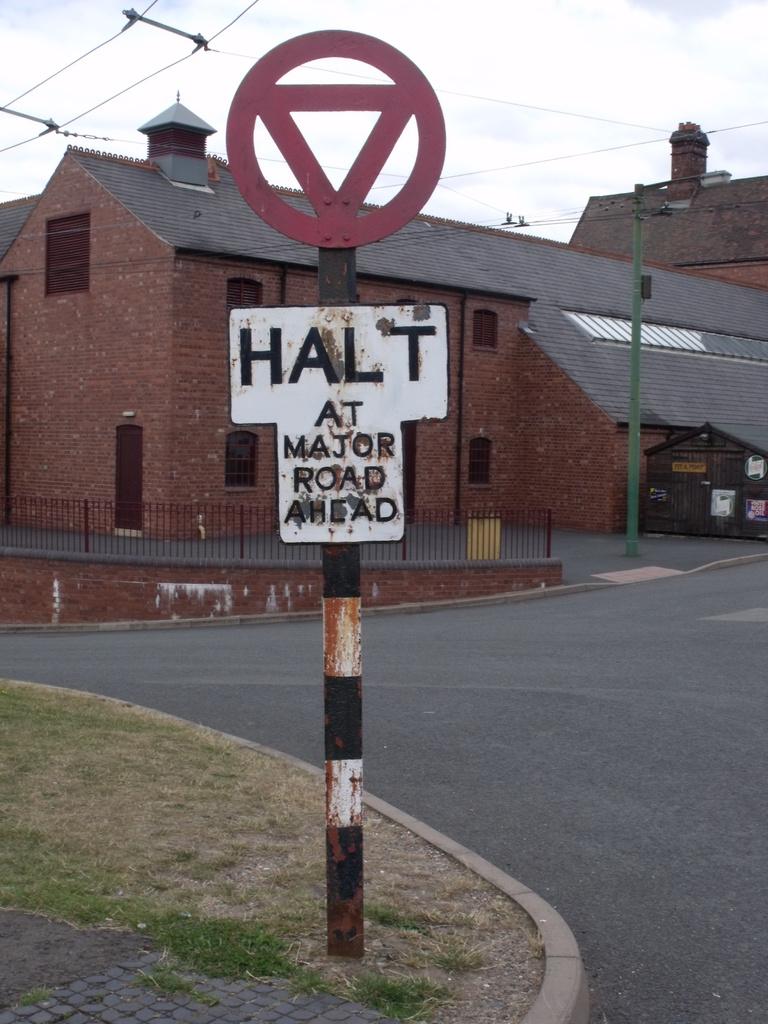Should we stop ahead?
Offer a very short reply. Yes. What kind of road is ahead?
Offer a terse response. Major. 